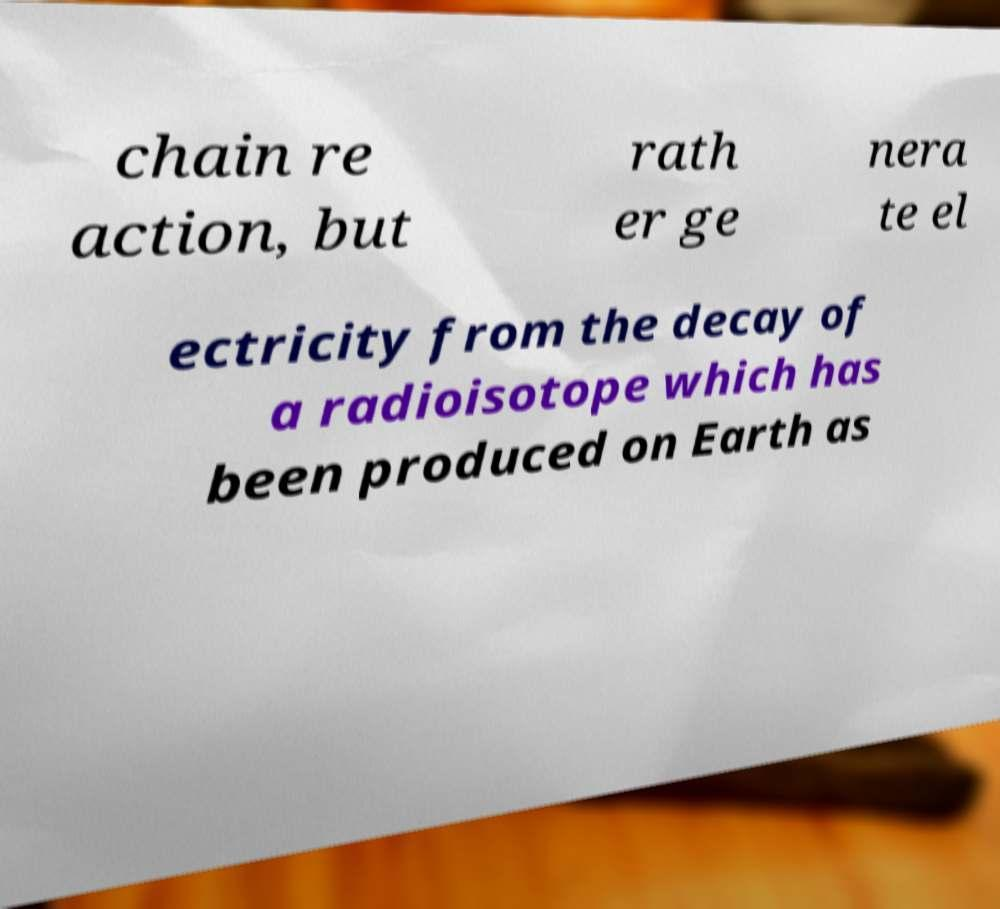Can you accurately transcribe the text from the provided image for me? chain re action, but rath er ge nera te el ectricity from the decay of a radioisotope which has been produced on Earth as 